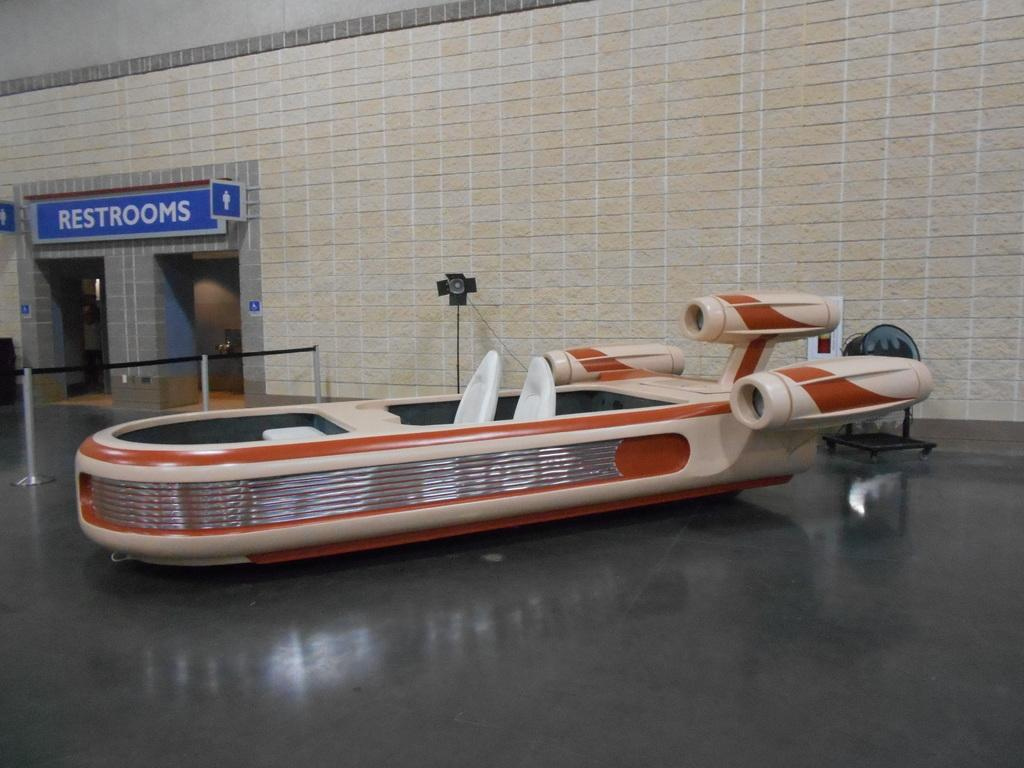What is the main subject of the image? The main subject of the image is a boat. What is the boat resting on in the image? The boat is on a black floor. What can be seen behind the boat? There is fencing and a wall behind the boat. What is attached to the wall on the left side of the image? Boards are attached to the wall on the left side of the image. What type of game is being played by the ghost in the image? There is no ghost present in the image, and therefore no game being played. 